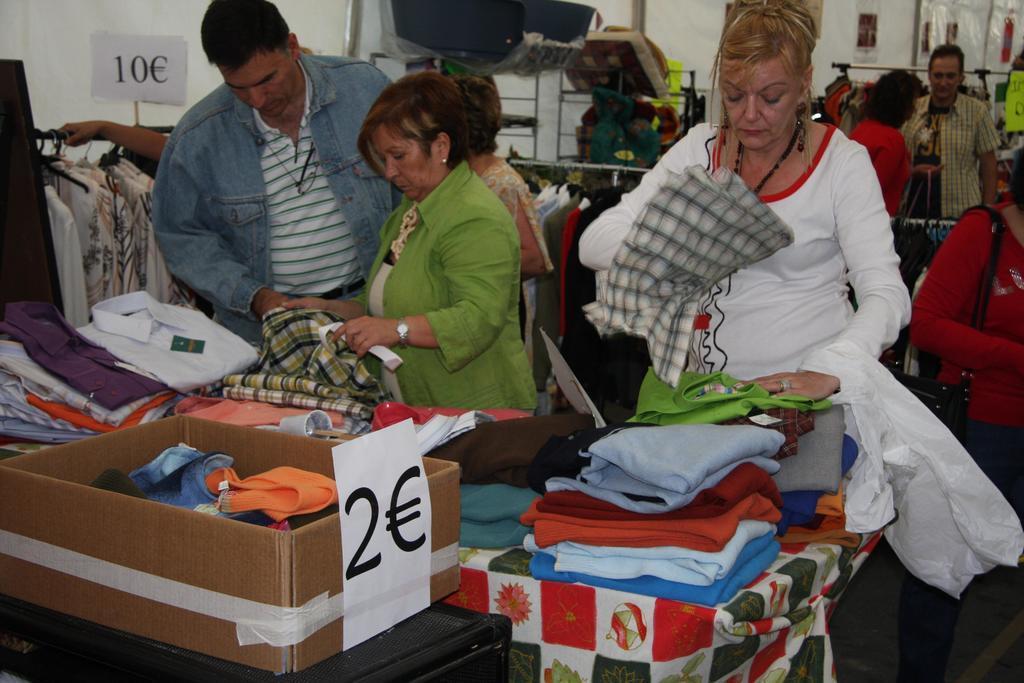Please provide a concise description of this image. In this image there are cloths on a table and there are people holding cloths in their hands and few are standing, in the background there are cloths hanged to poles. 